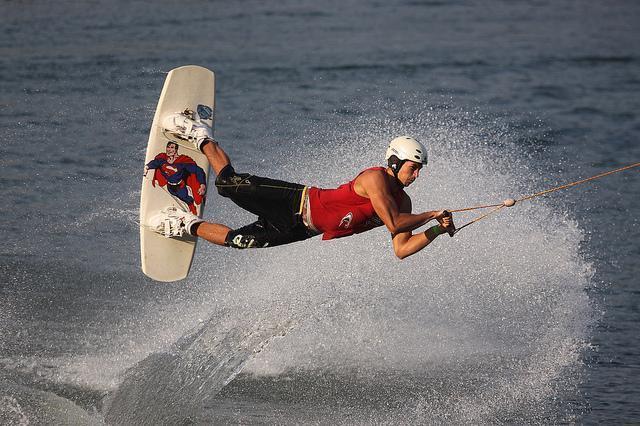How many cups are to the right of the plate?
Give a very brief answer. 0. 